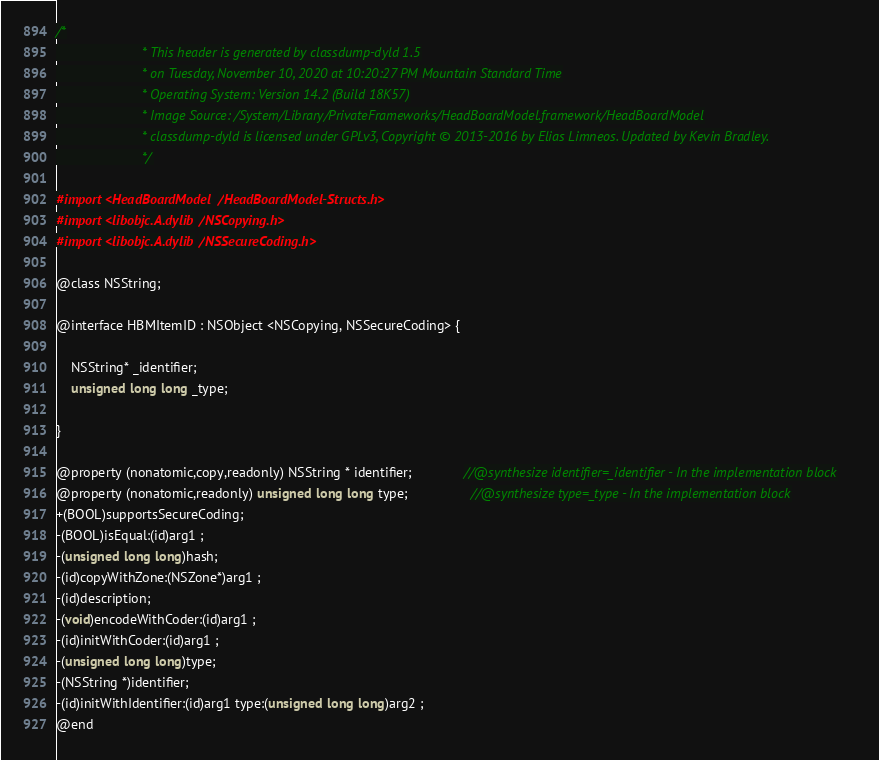Convert code to text. <code><loc_0><loc_0><loc_500><loc_500><_C_>/*
                       * This header is generated by classdump-dyld 1.5
                       * on Tuesday, November 10, 2020 at 10:20:27 PM Mountain Standard Time
                       * Operating System: Version 14.2 (Build 18K57)
                       * Image Source: /System/Library/PrivateFrameworks/HeadBoardModel.framework/HeadBoardModel
                       * classdump-dyld is licensed under GPLv3, Copyright © 2013-2016 by Elias Limneos. Updated by Kevin Bradley.
                       */

#import <HeadBoardModel/HeadBoardModel-Structs.h>
#import <libobjc.A.dylib/NSCopying.h>
#import <libobjc.A.dylib/NSSecureCoding.h>

@class NSString;

@interface HBMItemID : NSObject <NSCopying, NSSecureCoding> {

	NSString* _identifier;
	unsigned long long _type;

}

@property (nonatomic,copy,readonly) NSString * identifier;              //@synthesize identifier=_identifier - In the implementation block
@property (nonatomic,readonly) unsigned long long type;                 //@synthesize type=_type - In the implementation block
+(BOOL)supportsSecureCoding;
-(BOOL)isEqual:(id)arg1 ;
-(unsigned long long)hash;
-(id)copyWithZone:(NSZone*)arg1 ;
-(id)description;
-(void)encodeWithCoder:(id)arg1 ;
-(id)initWithCoder:(id)arg1 ;
-(unsigned long long)type;
-(NSString *)identifier;
-(id)initWithIdentifier:(id)arg1 type:(unsigned long long)arg2 ;
@end

</code> 